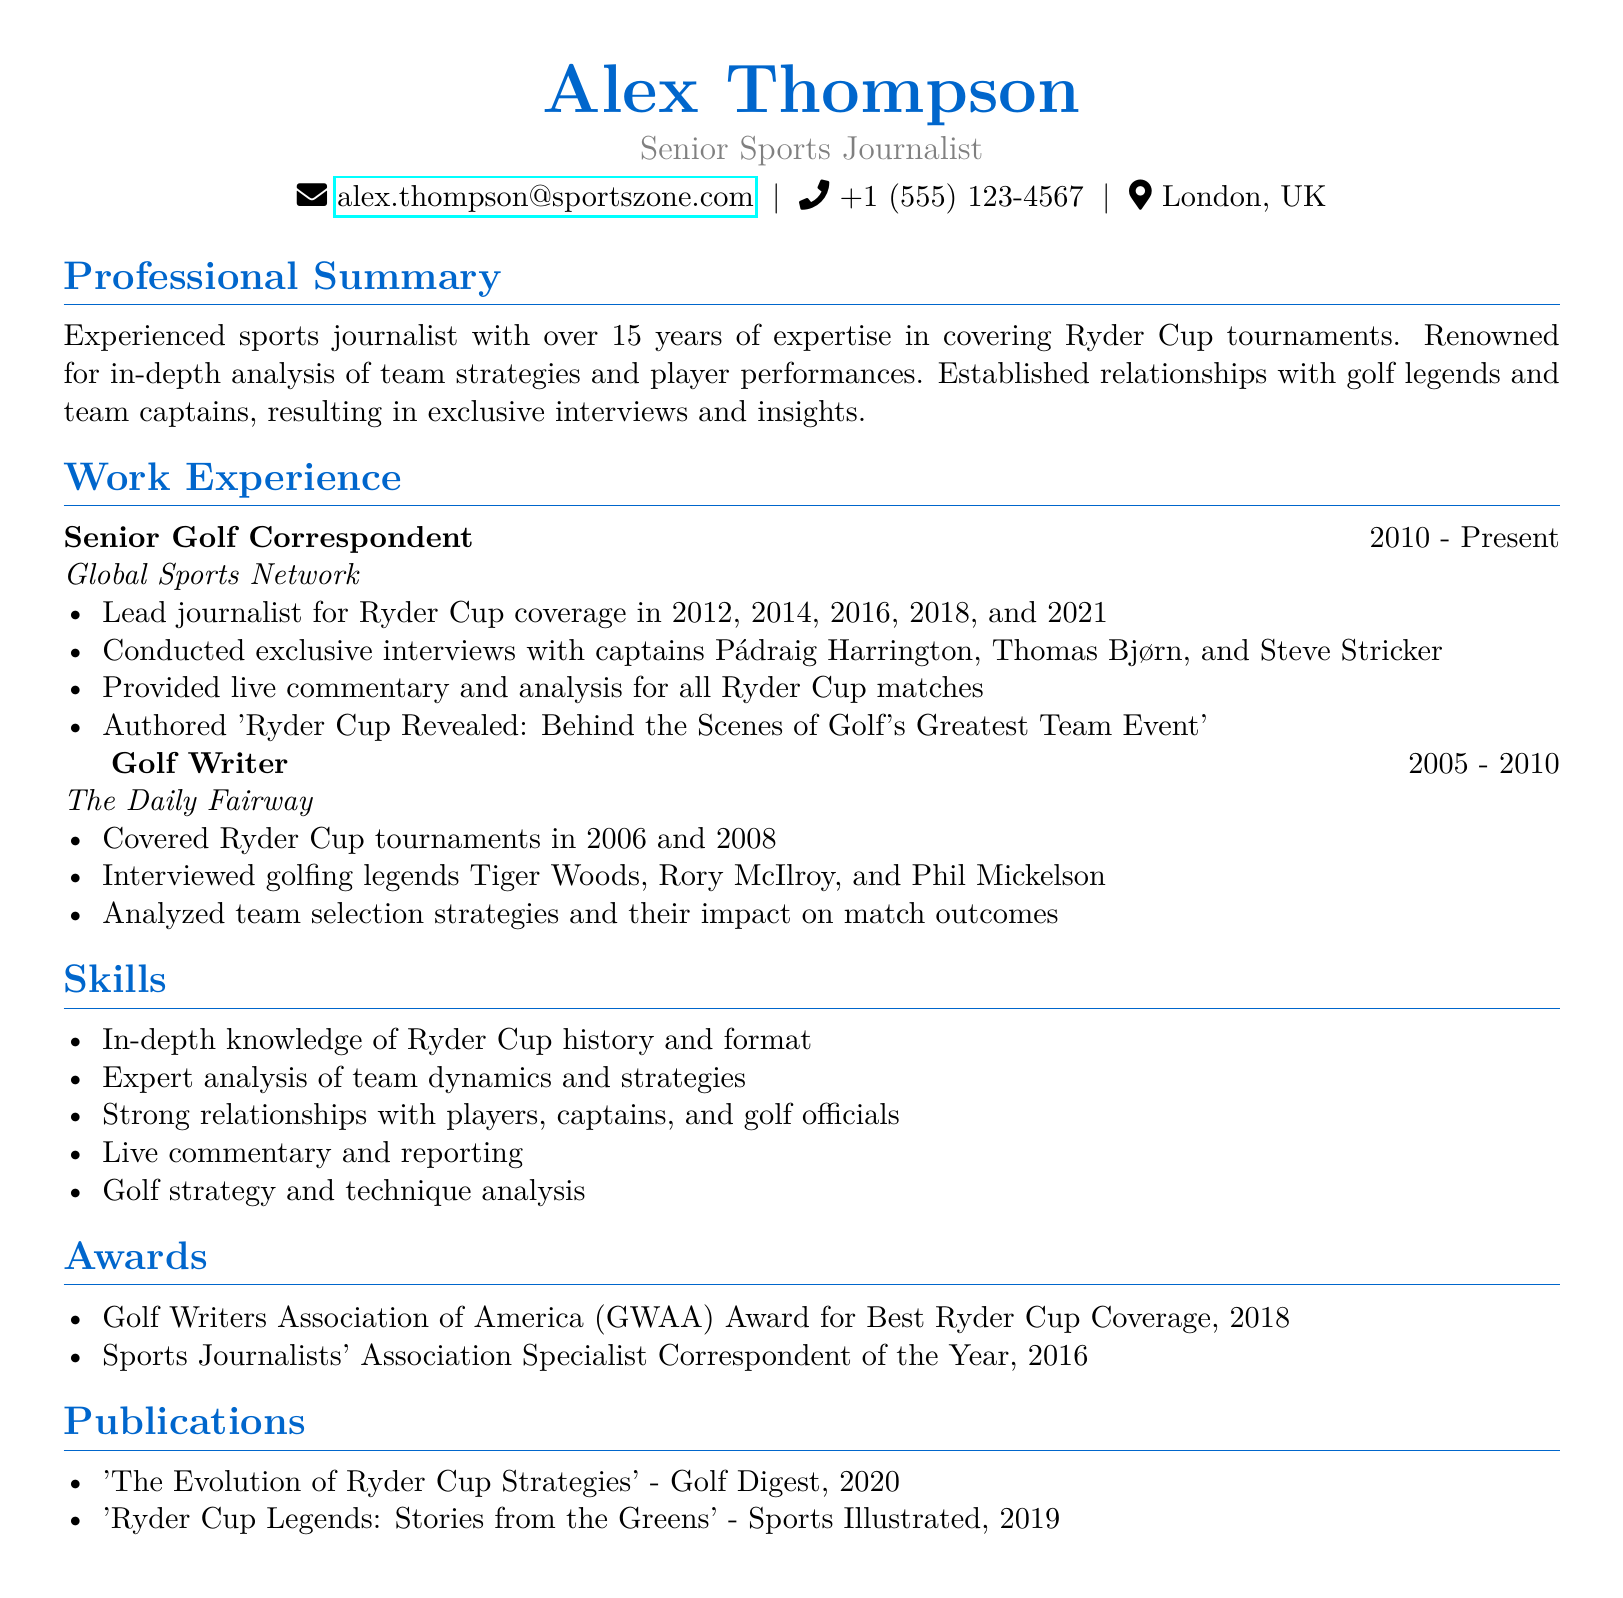What is the name of the journalist? The name of the journalist is Alex Thompson, as stated at the top of the document.
Answer: Alex Thompson What is the title of the CV? The title describes the position held by Alex Thompson, which is given under personal info.
Answer: Senior Sports Journalist Which organization did Alex Thompson work for as a Senior Golf Correspondent? The company listed for his current position is Global Sports Network.
Answer: Global Sports Network In what year did Alex begin his current role? The duration of his role as Senior Golf Correspondent shows he started in 2010.
Answer: 2010 Name one of the awards Alex Thompson has received. The awards section lists recognitions received during his career, one of which is the GWAA Award for Best Ryder Cup Coverage.
Answer: GWAA Award for Best Ryder Cup Coverage How many Ryder Cups did Alex Thompson cover as a Senior Golf Correspondent? The highlights in his work experience mention he covered Ryder Cup events in the years 2012, 2014, 2016, 2018, and 2021, totaling five tournaments.
Answer: 5 Which legendary player did Alex interview while working for The Daily Fairway? The highlights mention interviewing several legends, including Tiger Woods.
Answer: Tiger Woods What is the main focus of Alex's professional summary? The professional summary emphasizes his expertise in covering Ryder Cup tournaments and analyzing team strategies and player performances.
Answer: Ryder Cup tournaments How many publications are listed in the CV? The publications section details two specific articles authored by Alex Thompson relating to Ryder Cup strategies and legends.
Answer: 2 